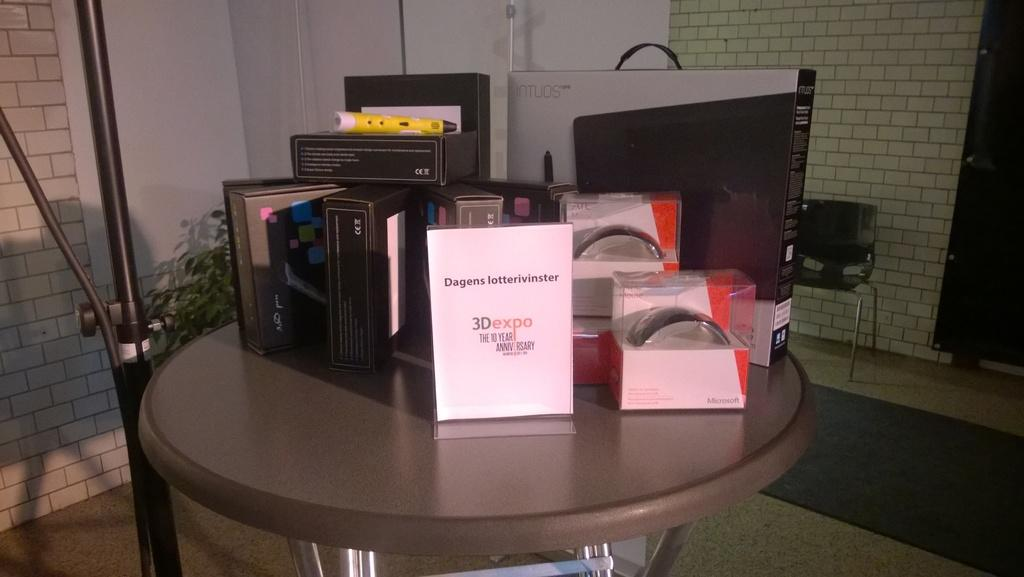Provide a one-sentence caption for the provided image. a 10 year anniversary special showcasing products for the 3D expo. 